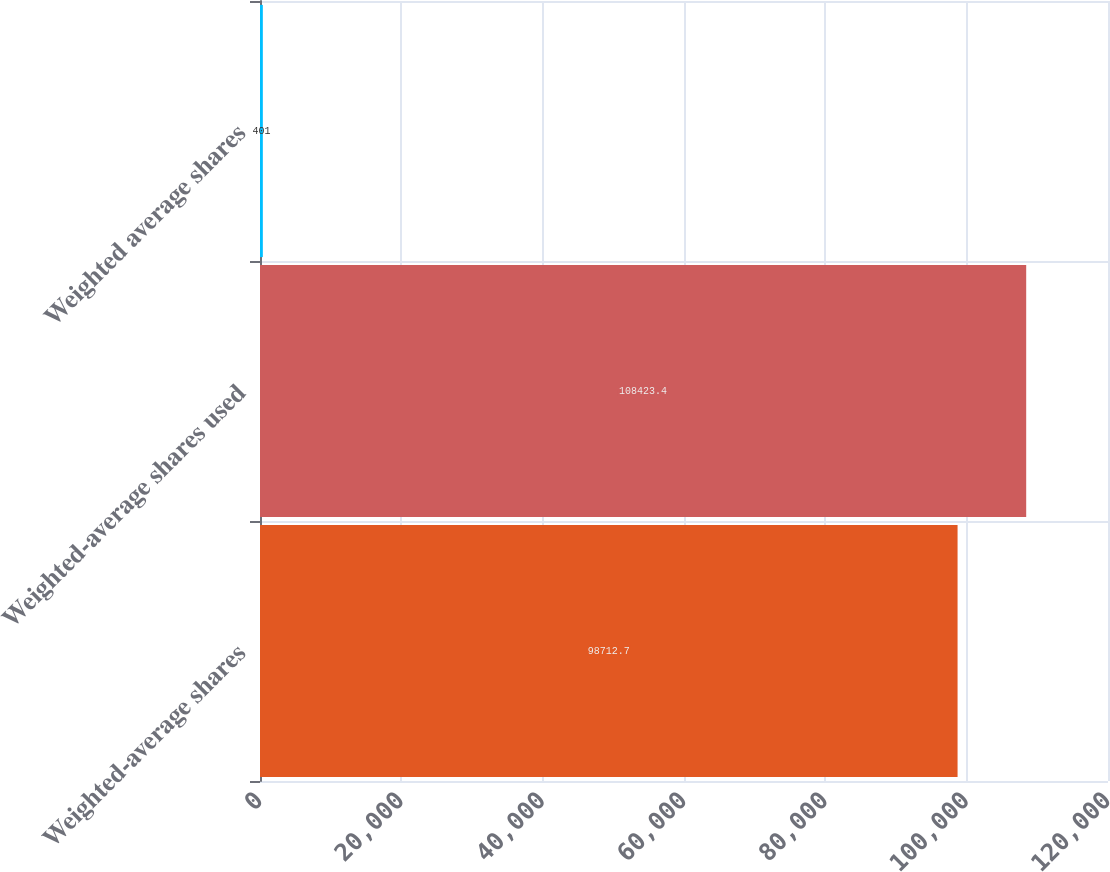Convert chart to OTSL. <chart><loc_0><loc_0><loc_500><loc_500><bar_chart><fcel>Weighted-average shares<fcel>Weighted-average shares used<fcel>Weighted average shares<nl><fcel>98712.7<fcel>108423<fcel>401<nl></chart> 